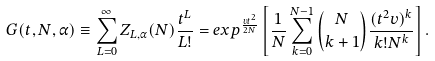<formula> <loc_0><loc_0><loc_500><loc_500>G ( t , N , \alpha ) \equiv \sum _ { L = 0 } ^ { \infty } Z _ { L , \alpha } ( N ) \frac { t ^ { L } } { L ! } = e x p ^ { \frac { v t ^ { 2 } } { 2 N } } \left [ \frac { 1 } { N } \sum _ { k = 0 } ^ { N - 1 } \binom { N } { k + 1 } \frac { ( t ^ { 2 } v ) ^ { k } } { k ! N ^ { k } } \right ] .</formula> 